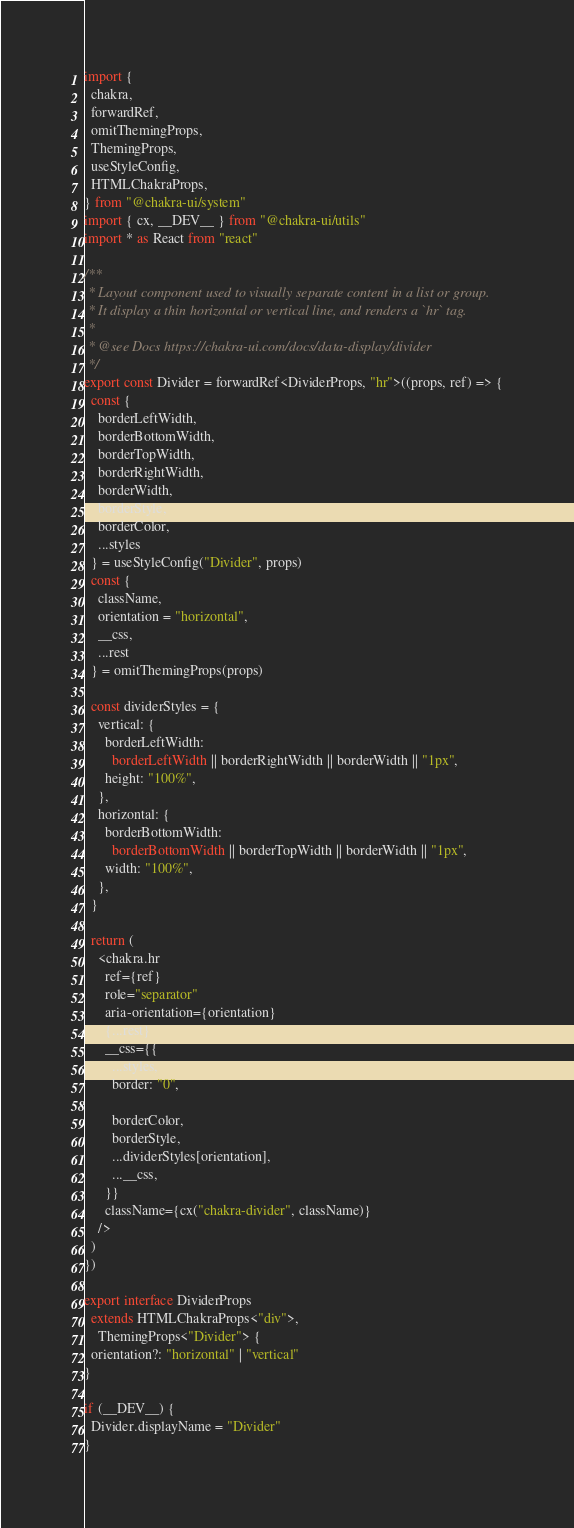<code> <loc_0><loc_0><loc_500><loc_500><_TypeScript_>import {
  chakra,
  forwardRef,
  omitThemingProps,
  ThemingProps,
  useStyleConfig,
  HTMLChakraProps,
} from "@chakra-ui/system"
import { cx, __DEV__ } from "@chakra-ui/utils"
import * as React from "react"

/**
 * Layout component used to visually separate content in a list or group.
 * It display a thin horizontal or vertical line, and renders a `hr` tag.
 *
 * @see Docs https://chakra-ui.com/docs/data-display/divider
 */
export const Divider = forwardRef<DividerProps, "hr">((props, ref) => {
  const {
    borderLeftWidth,
    borderBottomWidth,
    borderTopWidth,
    borderRightWidth,
    borderWidth,
    borderStyle,
    borderColor,
    ...styles
  } = useStyleConfig("Divider", props)
  const {
    className,
    orientation = "horizontal",
    __css,
    ...rest
  } = omitThemingProps(props)

  const dividerStyles = {
    vertical: {
      borderLeftWidth:
        borderLeftWidth || borderRightWidth || borderWidth || "1px",
      height: "100%",
    },
    horizontal: {
      borderBottomWidth:
        borderBottomWidth || borderTopWidth || borderWidth || "1px",
      width: "100%",
    },
  }

  return (
    <chakra.hr
      ref={ref}
      role="separator"
      aria-orientation={orientation}
      {...rest}
      __css={{
        ...styles,
        border: "0",

        borderColor,
        borderStyle,
        ...dividerStyles[orientation],
        ...__css,
      }}
      className={cx("chakra-divider", className)}
    />
  )
})

export interface DividerProps
  extends HTMLChakraProps<"div">,
    ThemingProps<"Divider"> {
  orientation?: "horizontal" | "vertical"
}

if (__DEV__) {
  Divider.displayName = "Divider"
}
</code> 